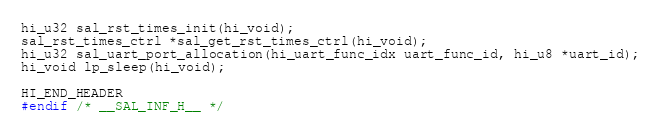<code> <loc_0><loc_0><loc_500><loc_500><_C_>hi_u32 sal_rst_times_init(hi_void);
sal_rst_times_ctrl *sal_get_rst_times_ctrl(hi_void);
hi_u32 sal_uart_port_allocation(hi_uart_func_idx uart_func_id, hi_u8 *uart_id);
hi_void lp_sleep(hi_void);

HI_END_HEADER
#endif /* __SAL_INF_H__ */

</code> 